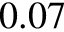Convert formula to latex. <formula><loc_0><loc_0><loc_500><loc_500>0 . 0 7</formula> 